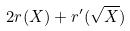Convert formula to latex. <formula><loc_0><loc_0><loc_500><loc_500>2 r ( X ) + r ^ { \prime } ( \sqrt { X } )</formula> 